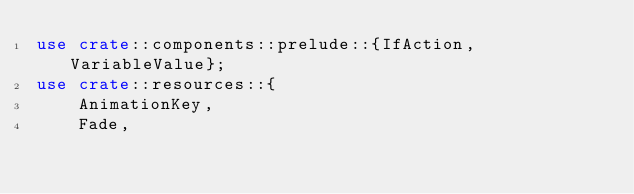<code> <loc_0><loc_0><loc_500><loc_500><_Rust_>use crate::components::prelude::{IfAction, VariableValue};
use crate::resources::{
    AnimationKey,
    Fade,</code> 